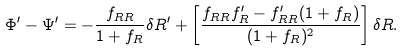Convert formula to latex. <formula><loc_0><loc_0><loc_500><loc_500>\Phi ^ { \prime } - \Psi ^ { \prime } = - \frac { f _ { R R } } { 1 + f _ { R } } \delta R ^ { \prime } + \left [ \frac { f _ { R R } f _ { R } ^ { \prime } - f _ { R R } ^ { \prime } ( 1 + f _ { R } ) } { ( 1 + f _ { R } ) ^ { 2 } } \right ] \delta R .</formula> 